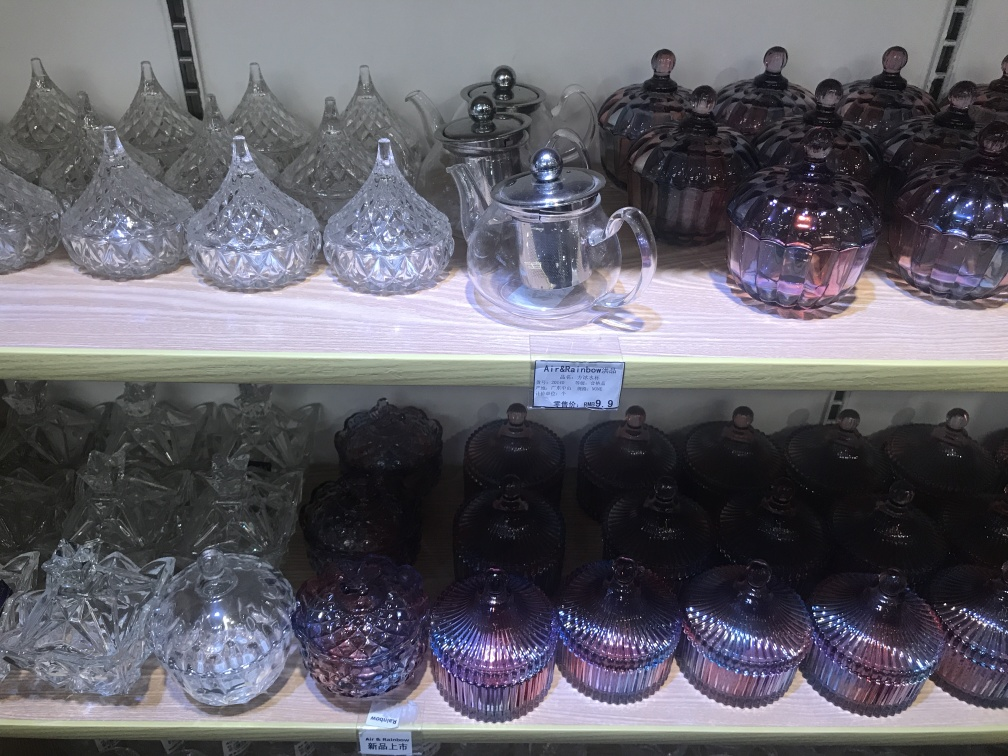Can you tell me what materials these items are made of? The teapot and containers in this image appear to be made of glass and possibly colored crystal, evidenced by their transparency and the way they reflect light. Some items possess a metallic sheen, suggesting a type of iridescent glass coating or finish. 